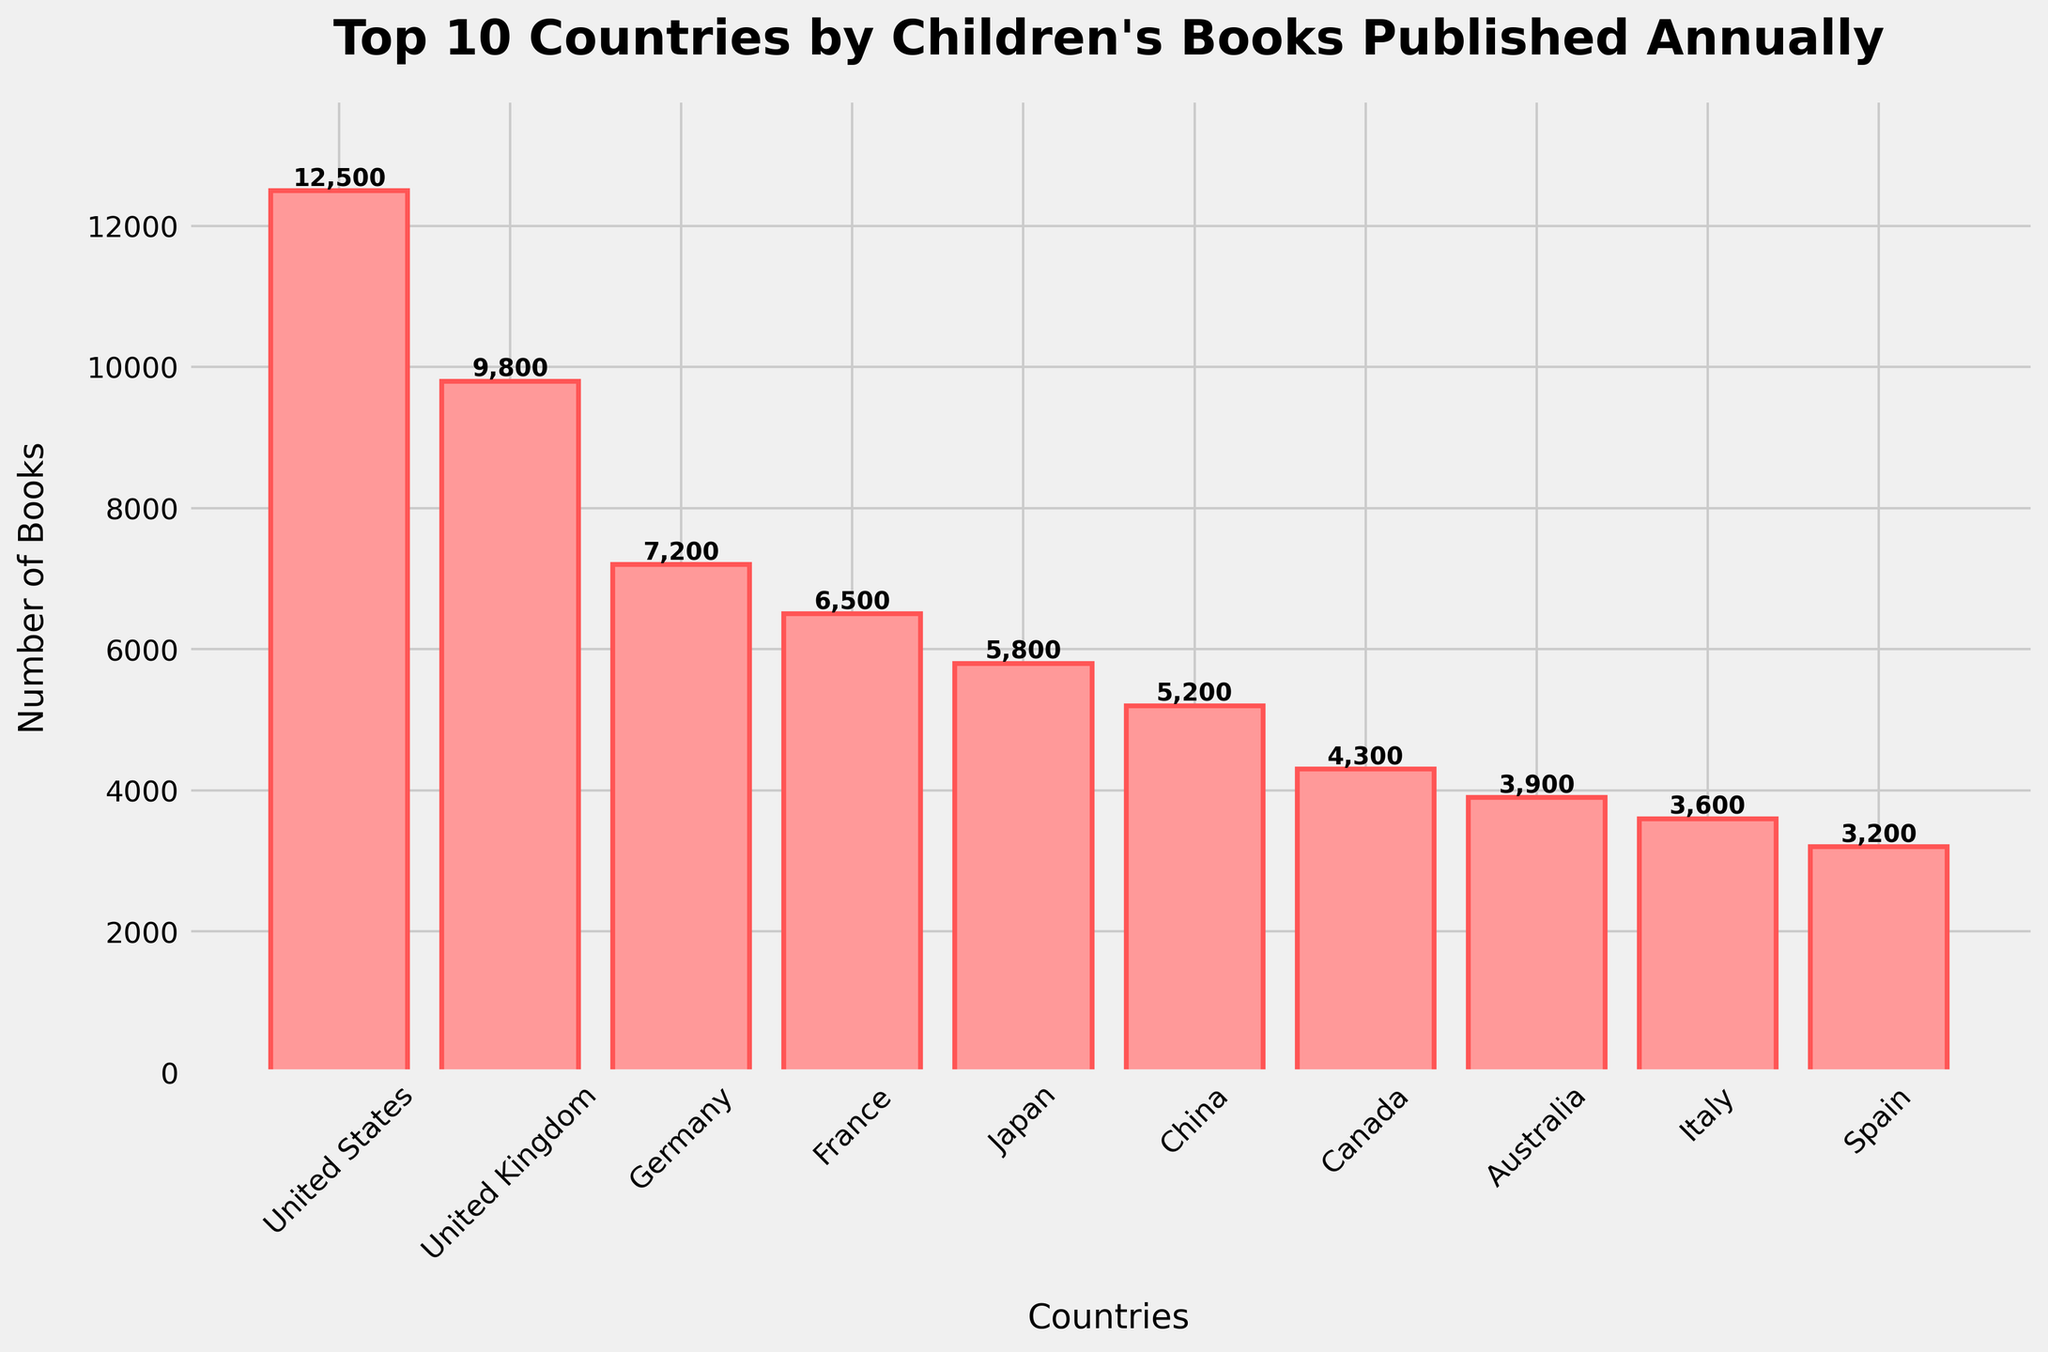Which country publishes the most children's books annually? The bar representing the United States is the tallest, indicating it publishes the highest number of children's books annually
Answer: United States How many children's books are published annually by Japan and Spain combined? Japan publishes 5,800 books and Spain publishes 3,200 books. Adding them together: 5,800 + 3,200 = 9,000
Answer: 9,000 Which country publishes more children's books annually, Germany or France? Comparing the heights of the bars, Germany's bar is taller than France's. Germany publishes 7,200 books and France publishes 6,500 books annually
Answer: Germany What's the average number of children's books published annually by the top 3 countries? The top 3 countries are the United States (12,500), United Kingdom (9,800), and Germany (7,200). Average = (12,500 + 9,800 + 7,200) / 3 = 29,500 / 3 ≈ 9,833
Answer: 9,833 How much more books does Canada publish annually compared to Italy? Canada publishes 4,300 books and Italy publishes 3,600 books. The difference is 4,300 - 3,600 = 700
Answer: 700 Which countries publish fewer children's books than Australia? Check the bar heights. Spain and Italy have shorter bars than Australia. Spain publishes 3,200 books and Italy publishes 3,600 books, both less than Australia's 3,900
Answer: Spain and Italy How does the number of books published by China compare to that of Japan? China's bar is shorter than Japan's. China publishes 5,200 books while Japan publishes 5,800 books. China publishes 600 fewer books than Japan
Answer: China publishes fewer What is the total number of children's books published annually by all top 10 countries? Sum the values: 12,500 (US) + 9,800 (UK) + 7,200 (Germany) + 6,500 (France) + 5,800 (Japan) + 5,200 (China) + 4,300 (Canada) + 3,900 (Australia) + 3,600 (Italy) + 3,200 (Spain) = 62,000
Answer: 62,000 Which countries' bars are colored in red? Observing the bar chart, all bars representing each country are colored in red with slight variations in hue
Answer: All countries What percentage of the total number of children's books are published by the United States alone? Total books published by all countries is 62,000. The US publishes 12,500. Percentage = (12,500 / 62,000) * 100 ≈ 20.16
Answer: ≈ 20.16% 